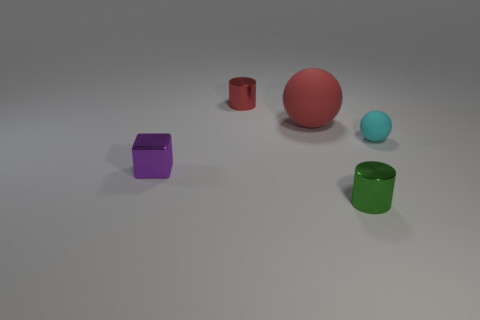What shape is the other object that is the same color as the large rubber thing?
Your response must be concise. Cylinder. What number of shiny objects have the same color as the large matte thing?
Your answer should be very brief. 1. There is a metal cube that is the same size as the green metallic thing; what color is it?
Your answer should be very brief. Purple. What number of rubber things are tiny red cylinders or tiny green cylinders?
Keep it short and to the point. 0. There is a metal cylinder behind the large matte thing; what number of red things are left of it?
Make the answer very short. 0. The other object that is the same color as the large matte thing is what size?
Keep it short and to the point. Small. How many objects are either gray metal cylinders or tiny metallic blocks on the left side of the small red object?
Give a very brief answer. 1. Are there any yellow cubes made of the same material as the purple thing?
Ensure brevity in your answer.  No. What number of tiny objects are to the left of the cyan rubber sphere and in front of the red cylinder?
Your answer should be compact. 2. There is a cylinder behind the large matte ball; what is its material?
Provide a succinct answer. Metal. 